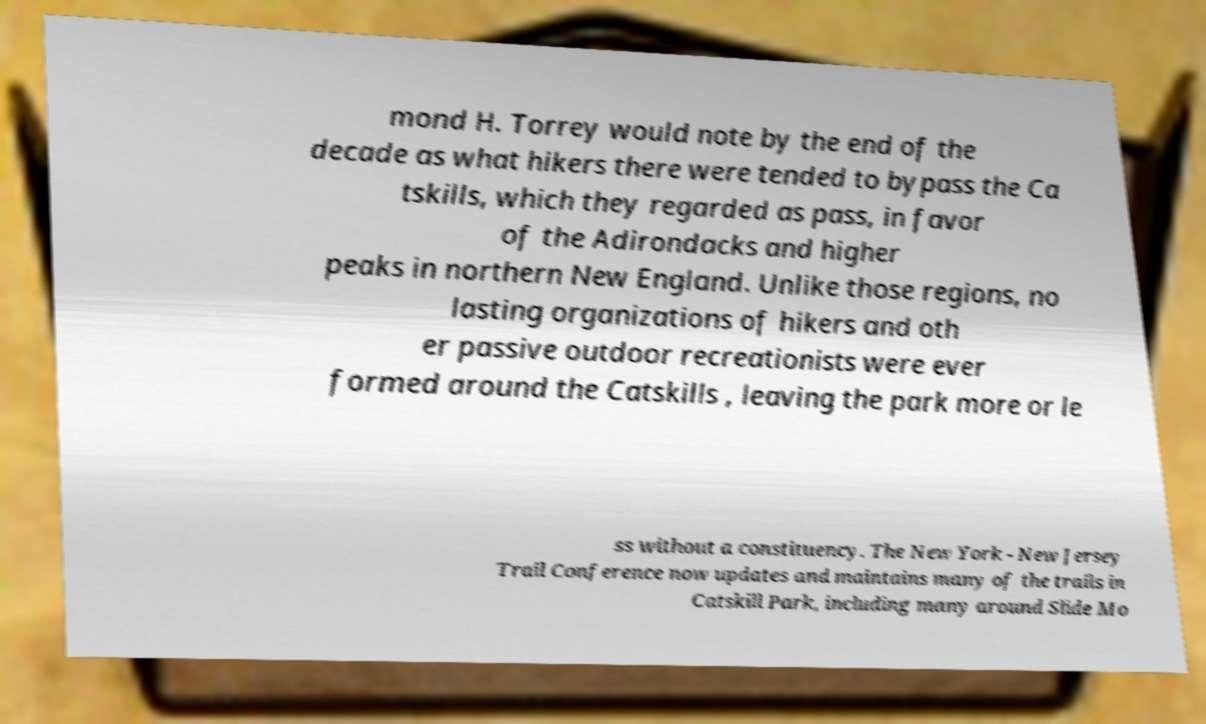Can you read and provide the text displayed in the image?This photo seems to have some interesting text. Can you extract and type it out for me? mond H. Torrey would note by the end of the decade as what hikers there were tended to bypass the Ca tskills, which they regarded as pass, in favor of the Adirondacks and higher peaks in northern New England. Unlike those regions, no lasting organizations of hikers and oth er passive outdoor recreationists were ever formed around the Catskills , leaving the park more or le ss without a constituency. The New York - New Jersey Trail Conference now updates and maintains many of the trails in Catskill Park, including many around Slide Mo 